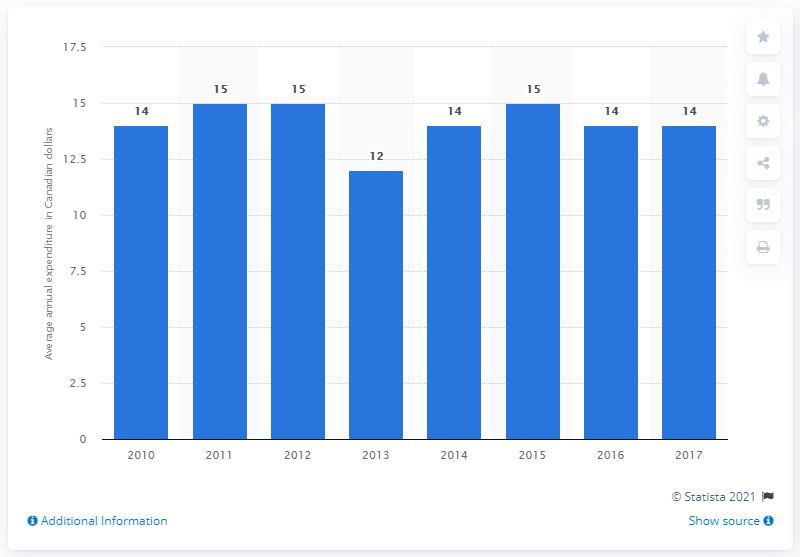Identify some key points in this picture. From 2014 to 2017, the sum is 57. According to data from 2017, the average annual household expenditure on microwave ovens in Canada was approximately CAD 140. The blue bar represents the average annual expenditure in Canadian dollars. 